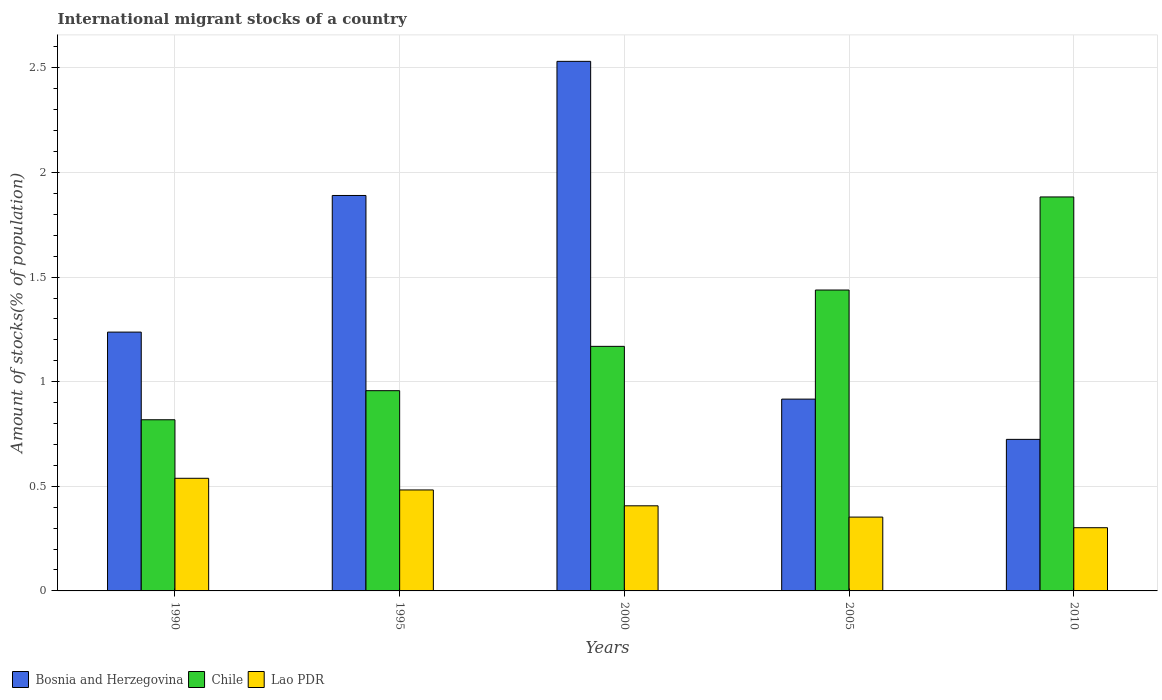Are the number of bars per tick equal to the number of legend labels?
Offer a terse response. Yes. How many bars are there on the 2nd tick from the right?
Offer a very short reply. 3. In how many cases, is the number of bars for a given year not equal to the number of legend labels?
Offer a terse response. 0. What is the amount of stocks in in Bosnia and Herzegovina in 1990?
Your response must be concise. 1.24. Across all years, what is the maximum amount of stocks in in Chile?
Provide a succinct answer. 1.88. Across all years, what is the minimum amount of stocks in in Bosnia and Herzegovina?
Provide a succinct answer. 0.72. In which year was the amount of stocks in in Chile maximum?
Give a very brief answer. 2010. In which year was the amount of stocks in in Chile minimum?
Your answer should be compact. 1990. What is the total amount of stocks in in Chile in the graph?
Your answer should be compact. 6.27. What is the difference between the amount of stocks in in Chile in 1995 and that in 2000?
Make the answer very short. -0.21. What is the difference between the amount of stocks in in Bosnia and Herzegovina in 2000 and the amount of stocks in in Chile in 2005?
Offer a terse response. 1.09. What is the average amount of stocks in in Lao PDR per year?
Your response must be concise. 0.42. In the year 1995, what is the difference between the amount of stocks in in Chile and amount of stocks in in Lao PDR?
Your response must be concise. 0.47. In how many years, is the amount of stocks in in Chile greater than 1.5 %?
Offer a very short reply. 1. What is the ratio of the amount of stocks in in Bosnia and Herzegovina in 1990 to that in 2005?
Offer a very short reply. 1.35. What is the difference between the highest and the second highest amount of stocks in in Chile?
Make the answer very short. 0.44. What is the difference between the highest and the lowest amount of stocks in in Bosnia and Herzegovina?
Provide a short and direct response. 1.81. In how many years, is the amount of stocks in in Bosnia and Herzegovina greater than the average amount of stocks in in Bosnia and Herzegovina taken over all years?
Provide a short and direct response. 2. Is the sum of the amount of stocks in in Chile in 1990 and 2000 greater than the maximum amount of stocks in in Bosnia and Herzegovina across all years?
Provide a short and direct response. No. What does the 3rd bar from the left in 2000 represents?
Provide a short and direct response. Lao PDR. What does the 1st bar from the right in 2000 represents?
Provide a succinct answer. Lao PDR. Is it the case that in every year, the sum of the amount of stocks in in Lao PDR and amount of stocks in in Chile is greater than the amount of stocks in in Bosnia and Herzegovina?
Offer a terse response. No. Does the graph contain any zero values?
Your response must be concise. No. Does the graph contain grids?
Keep it short and to the point. Yes. Where does the legend appear in the graph?
Your answer should be compact. Bottom left. How many legend labels are there?
Your answer should be compact. 3. How are the legend labels stacked?
Provide a short and direct response. Horizontal. What is the title of the graph?
Your answer should be compact. International migrant stocks of a country. What is the label or title of the Y-axis?
Your response must be concise. Amount of stocks(% of population). What is the Amount of stocks(% of population) in Bosnia and Herzegovina in 1990?
Your response must be concise. 1.24. What is the Amount of stocks(% of population) of Chile in 1990?
Ensure brevity in your answer.  0.82. What is the Amount of stocks(% of population) in Lao PDR in 1990?
Ensure brevity in your answer.  0.54. What is the Amount of stocks(% of population) in Bosnia and Herzegovina in 1995?
Keep it short and to the point. 1.89. What is the Amount of stocks(% of population) in Chile in 1995?
Make the answer very short. 0.96. What is the Amount of stocks(% of population) in Lao PDR in 1995?
Offer a very short reply. 0.48. What is the Amount of stocks(% of population) in Bosnia and Herzegovina in 2000?
Your response must be concise. 2.53. What is the Amount of stocks(% of population) of Chile in 2000?
Provide a succinct answer. 1.17. What is the Amount of stocks(% of population) of Lao PDR in 2000?
Provide a succinct answer. 0.41. What is the Amount of stocks(% of population) of Bosnia and Herzegovina in 2005?
Make the answer very short. 0.92. What is the Amount of stocks(% of population) of Chile in 2005?
Keep it short and to the point. 1.44. What is the Amount of stocks(% of population) in Lao PDR in 2005?
Your response must be concise. 0.35. What is the Amount of stocks(% of population) in Bosnia and Herzegovina in 2010?
Make the answer very short. 0.72. What is the Amount of stocks(% of population) in Chile in 2010?
Your answer should be compact. 1.88. What is the Amount of stocks(% of population) of Lao PDR in 2010?
Make the answer very short. 0.3. Across all years, what is the maximum Amount of stocks(% of population) of Bosnia and Herzegovina?
Give a very brief answer. 2.53. Across all years, what is the maximum Amount of stocks(% of population) in Chile?
Your answer should be compact. 1.88. Across all years, what is the maximum Amount of stocks(% of population) of Lao PDR?
Offer a terse response. 0.54. Across all years, what is the minimum Amount of stocks(% of population) of Bosnia and Herzegovina?
Provide a succinct answer. 0.72. Across all years, what is the minimum Amount of stocks(% of population) of Chile?
Provide a short and direct response. 0.82. Across all years, what is the minimum Amount of stocks(% of population) in Lao PDR?
Make the answer very short. 0.3. What is the total Amount of stocks(% of population) in Bosnia and Herzegovina in the graph?
Your answer should be compact. 7.3. What is the total Amount of stocks(% of population) of Chile in the graph?
Provide a short and direct response. 6.27. What is the total Amount of stocks(% of population) in Lao PDR in the graph?
Your answer should be very brief. 2.08. What is the difference between the Amount of stocks(% of population) in Bosnia and Herzegovina in 1990 and that in 1995?
Your answer should be very brief. -0.65. What is the difference between the Amount of stocks(% of population) in Chile in 1990 and that in 1995?
Give a very brief answer. -0.14. What is the difference between the Amount of stocks(% of population) of Lao PDR in 1990 and that in 1995?
Make the answer very short. 0.06. What is the difference between the Amount of stocks(% of population) in Bosnia and Herzegovina in 1990 and that in 2000?
Your response must be concise. -1.29. What is the difference between the Amount of stocks(% of population) in Chile in 1990 and that in 2000?
Offer a very short reply. -0.35. What is the difference between the Amount of stocks(% of population) in Lao PDR in 1990 and that in 2000?
Your answer should be compact. 0.13. What is the difference between the Amount of stocks(% of population) in Bosnia and Herzegovina in 1990 and that in 2005?
Provide a succinct answer. 0.32. What is the difference between the Amount of stocks(% of population) of Chile in 1990 and that in 2005?
Your answer should be very brief. -0.62. What is the difference between the Amount of stocks(% of population) in Lao PDR in 1990 and that in 2005?
Your answer should be very brief. 0.19. What is the difference between the Amount of stocks(% of population) of Bosnia and Herzegovina in 1990 and that in 2010?
Keep it short and to the point. 0.51. What is the difference between the Amount of stocks(% of population) of Chile in 1990 and that in 2010?
Provide a short and direct response. -1.06. What is the difference between the Amount of stocks(% of population) of Lao PDR in 1990 and that in 2010?
Give a very brief answer. 0.24. What is the difference between the Amount of stocks(% of population) of Bosnia and Herzegovina in 1995 and that in 2000?
Your answer should be very brief. -0.64. What is the difference between the Amount of stocks(% of population) in Chile in 1995 and that in 2000?
Your response must be concise. -0.21. What is the difference between the Amount of stocks(% of population) of Lao PDR in 1995 and that in 2000?
Give a very brief answer. 0.08. What is the difference between the Amount of stocks(% of population) in Bosnia and Herzegovina in 1995 and that in 2005?
Offer a terse response. 0.97. What is the difference between the Amount of stocks(% of population) in Chile in 1995 and that in 2005?
Keep it short and to the point. -0.48. What is the difference between the Amount of stocks(% of population) of Lao PDR in 1995 and that in 2005?
Your answer should be very brief. 0.13. What is the difference between the Amount of stocks(% of population) of Bosnia and Herzegovina in 1995 and that in 2010?
Give a very brief answer. 1.17. What is the difference between the Amount of stocks(% of population) of Chile in 1995 and that in 2010?
Offer a terse response. -0.93. What is the difference between the Amount of stocks(% of population) in Lao PDR in 1995 and that in 2010?
Provide a short and direct response. 0.18. What is the difference between the Amount of stocks(% of population) in Bosnia and Herzegovina in 2000 and that in 2005?
Provide a succinct answer. 1.61. What is the difference between the Amount of stocks(% of population) in Chile in 2000 and that in 2005?
Give a very brief answer. -0.27. What is the difference between the Amount of stocks(% of population) of Lao PDR in 2000 and that in 2005?
Give a very brief answer. 0.05. What is the difference between the Amount of stocks(% of population) of Bosnia and Herzegovina in 2000 and that in 2010?
Give a very brief answer. 1.81. What is the difference between the Amount of stocks(% of population) of Chile in 2000 and that in 2010?
Offer a terse response. -0.71. What is the difference between the Amount of stocks(% of population) in Lao PDR in 2000 and that in 2010?
Make the answer very short. 0.1. What is the difference between the Amount of stocks(% of population) of Bosnia and Herzegovina in 2005 and that in 2010?
Provide a succinct answer. 0.19. What is the difference between the Amount of stocks(% of population) in Chile in 2005 and that in 2010?
Make the answer very short. -0.44. What is the difference between the Amount of stocks(% of population) in Lao PDR in 2005 and that in 2010?
Keep it short and to the point. 0.05. What is the difference between the Amount of stocks(% of population) in Bosnia and Herzegovina in 1990 and the Amount of stocks(% of population) in Chile in 1995?
Provide a succinct answer. 0.28. What is the difference between the Amount of stocks(% of population) of Bosnia and Herzegovina in 1990 and the Amount of stocks(% of population) of Lao PDR in 1995?
Your response must be concise. 0.75. What is the difference between the Amount of stocks(% of population) in Chile in 1990 and the Amount of stocks(% of population) in Lao PDR in 1995?
Your answer should be compact. 0.34. What is the difference between the Amount of stocks(% of population) of Bosnia and Herzegovina in 1990 and the Amount of stocks(% of population) of Chile in 2000?
Your response must be concise. 0.07. What is the difference between the Amount of stocks(% of population) of Bosnia and Herzegovina in 1990 and the Amount of stocks(% of population) of Lao PDR in 2000?
Keep it short and to the point. 0.83. What is the difference between the Amount of stocks(% of population) in Chile in 1990 and the Amount of stocks(% of population) in Lao PDR in 2000?
Offer a very short reply. 0.41. What is the difference between the Amount of stocks(% of population) in Bosnia and Herzegovina in 1990 and the Amount of stocks(% of population) in Chile in 2005?
Provide a succinct answer. -0.2. What is the difference between the Amount of stocks(% of population) of Bosnia and Herzegovina in 1990 and the Amount of stocks(% of population) of Lao PDR in 2005?
Keep it short and to the point. 0.88. What is the difference between the Amount of stocks(% of population) in Chile in 1990 and the Amount of stocks(% of population) in Lao PDR in 2005?
Ensure brevity in your answer.  0.47. What is the difference between the Amount of stocks(% of population) in Bosnia and Herzegovina in 1990 and the Amount of stocks(% of population) in Chile in 2010?
Give a very brief answer. -0.65. What is the difference between the Amount of stocks(% of population) in Bosnia and Herzegovina in 1990 and the Amount of stocks(% of population) in Lao PDR in 2010?
Provide a succinct answer. 0.93. What is the difference between the Amount of stocks(% of population) of Chile in 1990 and the Amount of stocks(% of population) of Lao PDR in 2010?
Your answer should be very brief. 0.52. What is the difference between the Amount of stocks(% of population) in Bosnia and Herzegovina in 1995 and the Amount of stocks(% of population) in Chile in 2000?
Provide a short and direct response. 0.72. What is the difference between the Amount of stocks(% of population) in Bosnia and Herzegovina in 1995 and the Amount of stocks(% of population) in Lao PDR in 2000?
Ensure brevity in your answer.  1.48. What is the difference between the Amount of stocks(% of population) in Chile in 1995 and the Amount of stocks(% of population) in Lao PDR in 2000?
Give a very brief answer. 0.55. What is the difference between the Amount of stocks(% of population) of Bosnia and Herzegovina in 1995 and the Amount of stocks(% of population) of Chile in 2005?
Ensure brevity in your answer.  0.45. What is the difference between the Amount of stocks(% of population) in Bosnia and Herzegovina in 1995 and the Amount of stocks(% of population) in Lao PDR in 2005?
Ensure brevity in your answer.  1.54. What is the difference between the Amount of stocks(% of population) of Chile in 1995 and the Amount of stocks(% of population) of Lao PDR in 2005?
Your answer should be compact. 0.6. What is the difference between the Amount of stocks(% of population) of Bosnia and Herzegovina in 1995 and the Amount of stocks(% of population) of Chile in 2010?
Make the answer very short. 0.01. What is the difference between the Amount of stocks(% of population) in Bosnia and Herzegovina in 1995 and the Amount of stocks(% of population) in Lao PDR in 2010?
Keep it short and to the point. 1.59. What is the difference between the Amount of stocks(% of population) in Chile in 1995 and the Amount of stocks(% of population) in Lao PDR in 2010?
Give a very brief answer. 0.65. What is the difference between the Amount of stocks(% of population) in Bosnia and Herzegovina in 2000 and the Amount of stocks(% of population) in Chile in 2005?
Give a very brief answer. 1.09. What is the difference between the Amount of stocks(% of population) of Bosnia and Herzegovina in 2000 and the Amount of stocks(% of population) of Lao PDR in 2005?
Provide a succinct answer. 2.18. What is the difference between the Amount of stocks(% of population) of Chile in 2000 and the Amount of stocks(% of population) of Lao PDR in 2005?
Ensure brevity in your answer.  0.82. What is the difference between the Amount of stocks(% of population) in Bosnia and Herzegovina in 2000 and the Amount of stocks(% of population) in Chile in 2010?
Keep it short and to the point. 0.65. What is the difference between the Amount of stocks(% of population) in Bosnia and Herzegovina in 2000 and the Amount of stocks(% of population) in Lao PDR in 2010?
Offer a very short reply. 2.23. What is the difference between the Amount of stocks(% of population) of Chile in 2000 and the Amount of stocks(% of population) of Lao PDR in 2010?
Provide a short and direct response. 0.87. What is the difference between the Amount of stocks(% of population) of Bosnia and Herzegovina in 2005 and the Amount of stocks(% of population) of Chile in 2010?
Provide a short and direct response. -0.97. What is the difference between the Amount of stocks(% of population) in Bosnia and Herzegovina in 2005 and the Amount of stocks(% of population) in Lao PDR in 2010?
Give a very brief answer. 0.61. What is the difference between the Amount of stocks(% of population) in Chile in 2005 and the Amount of stocks(% of population) in Lao PDR in 2010?
Make the answer very short. 1.14. What is the average Amount of stocks(% of population) of Bosnia and Herzegovina per year?
Give a very brief answer. 1.46. What is the average Amount of stocks(% of population) in Chile per year?
Keep it short and to the point. 1.25. What is the average Amount of stocks(% of population) in Lao PDR per year?
Ensure brevity in your answer.  0.42. In the year 1990, what is the difference between the Amount of stocks(% of population) in Bosnia and Herzegovina and Amount of stocks(% of population) in Chile?
Provide a succinct answer. 0.42. In the year 1990, what is the difference between the Amount of stocks(% of population) in Bosnia and Herzegovina and Amount of stocks(% of population) in Lao PDR?
Give a very brief answer. 0.7. In the year 1990, what is the difference between the Amount of stocks(% of population) of Chile and Amount of stocks(% of population) of Lao PDR?
Make the answer very short. 0.28. In the year 1995, what is the difference between the Amount of stocks(% of population) in Bosnia and Herzegovina and Amount of stocks(% of population) in Chile?
Your response must be concise. 0.93. In the year 1995, what is the difference between the Amount of stocks(% of population) of Bosnia and Herzegovina and Amount of stocks(% of population) of Lao PDR?
Provide a short and direct response. 1.41. In the year 1995, what is the difference between the Amount of stocks(% of population) of Chile and Amount of stocks(% of population) of Lao PDR?
Provide a short and direct response. 0.47. In the year 2000, what is the difference between the Amount of stocks(% of population) of Bosnia and Herzegovina and Amount of stocks(% of population) of Chile?
Your answer should be compact. 1.36. In the year 2000, what is the difference between the Amount of stocks(% of population) of Bosnia and Herzegovina and Amount of stocks(% of population) of Lao PDR?
Offer a very short reply. 2.12. In the year 2000, what is the difference between the Amount of stocks(% of population) of Chile and Amount of stocks(% of population) of Lao PDR?
Your response must be concise. 0.76. In the year 2005, what is the difference between the Amount of stocks(% of population) in Bosnia and Herzegovina and Amount of stocks(% of population) in Chile?
Your response must be concise. -0.52. In the year 2005, what is the difference between the Amount of stocks(% of population) of Bosnia and Herzegovina and Amount of stocks(% of population) of Lao PDR?
Your answer should be compact. 0.56. In the year 2005, what is the difference between the Amount of stocks(% of population) in Chile and Amount of stocks(% of population) in Lao PDR?
Keep it short and to the point. 1.09. In the year 2010, what is the difference between the Amount of stocks(% of population) in Bosnia and Herzegovina and Amount of stocks(% of population) in Chile?
Your answer should be very brief. -1.16. In the year 2010, what is the difference between the Amount of stocks(% of population) in Bosnia and Herzegovina and Amount of stocks(% of population) in Lao PDR?
Provide a short and direct response. 0.42. In the year 2010, what is the difference between the Amount of stocks(% of population) in Chile and Amount of stocks(% of population) in Lao PDR?
Provide a succinct answer. 1.58. What is the ratio of the Amount of stocks(% of population) of Bosnia and Herzegovina in 1990 to that in 1995?
Give a very brief answer. 0.65. What is the ratio of the Amount of stocks(% of population) of Chile in 1990 to that in 1995?
Ensure brevity in your answer.  0.85. What is the ratio of the Amount of stocks(% of population) of Lao PDR in 1990 to that in 1995?
Provide a succinct answer. 1.12. What is the ratio of the Amount of stocks(% of population) of Bosnia and Herzegovina in 1990 to that in 2000?
Your response must be concise. 0.49. What is the ratio of the Amount of stocks(% of population) in Chile in 1990 to that in 2000?
Provide a short and direct response. 0.7. What is the ratio of the Amount of stocks(% of population) in Lao PDR in 1990 to that in 2000?
Give a very brief answer. 1.32. What is the ratio of the Amount of stocks(% of population) in Bosnia and Herzegovina in 1990 to that in 2005?
Your answer should be compact. 1.35. What is the ratio of the Amount of stocks(% of population) of Chile in 1990 to that in 2005?
Your answer should be very brief. 0.57. What is the ratio of the Amount of stocks(% of population) of Lao PDR in 1990 to that in 2005?
Give a very brief answer. 1.53. What is the ratio of the Amount of stocks(% of population) in Bosnia and Herzegovina in 1990 to that in 2010?
Make the answer very short. 1.71. What is the ratio of the Amount of stocks(% of population) in Chile in 1990 to that in 2010?
Your response must be concise. 0.43. What is the ratio of the Amount of stocks(% of population) in Lao PDR in 1990 to that in 2010?
Your response must be concise. 1.78. What is the ratio of the Amount of stocks(% of population) in Bosnia and Herzegovina in 1995 to that in 2000?
Keep it short and to the point. 0.75. What is the ratio of the Amount of stocks(% of population) in Chile in 1995 to that in 2000?
Offer a very short reply. 0.82. What is the ratio of the Amount of stocks(% of population) of Lao PDR in 1995 to that in 2000?
Your response must be concise. 1.19. What is the ratio of the Amount of stocks(% of population) in Bosnia and Herzegovina in 1995 to that in 2005?
Your response must be concise. 2.06. What is the ratio of the Amount of stocks(% of population) of Chile in 1995 to that in 2005?
Your response must be concise. 0.67. What is the ratio of the Amount of stocks(% of population) of Lao PDR in 1995 to that in 2005?
Your answer should be very brief. 1.37. What is the ratio of the Amount of stocks(% of population) of Bosnia and Herzegovina in 1995 to that in 2010?
Your answer should be very brief. 2.61. What is the ratio of the Amount of stocks(% of population) in Chile in 1995 to that in 2010?
Make the answer very short. 0.51. What is the ratio of the Amount of stocks(% of population) of Lao PDR in 1995 to that in 2010?
Make the answer very short. 1.6. What is the ratio of the Amount of stocks(% of population) in Bosnia and Herzegovina in 2000 to that in 2005?
Offer a terse response. 2.76. What is the ratio of the Amount of stocks(% of population) of Chile in 2000 to that in 2005?
Make the answer very short. 0.81. What is the ratio of the Amount of stocks(% of population) of Lao PDR in 2000 to that in 2005?
Give a very brief answer. 1.15. What is the ratio of the Amount of stocks(% of population) in Bosnia and Herzegovina in 2000 to that in 2010?
Keep it short and to the point. 3.49. What is the ratio of the Amount of stocks(% of population) in Chile in 2000 to that in 2010?
Provide a succinct answer. 0.62. What is the ratio of the Amount of stocks(% of population) of Lao PDR in 2000 to that in 2010?
Your answer should be compact. 1.35. What is the ratio of the Amount of stocks(% of population) in Bosnia and Herzegovina in 2005 to that in 2010?
Provide a short and direct response. 1.27. What is the ratio of the Amount of stocks(% of population) in Chile in 2005 to that in 2010?
Provide a succinct answer. 0.76. What is the ratio of the Amount of stocks(% of population) of Lao PDR in 2005 to that in 2010?
Make the answer very short. 1.17. What is the difference between the highest and the second highest Amount of stocks(% of population) of Bosnia and Herzegovina?
Provide a short and direct response. 0.64. What is the difference between the highest and the second highest Amount of stocks(% of population) in Chile?
Offer a very short reply. 0.44. What is the difference between the highest and the second highest Amount of stocks(% of population) of Lao PDR?
Make the answer very short. 0.06. What is the difference between the highest and the lowest Amount of stocks(% of population) in Bosnia and Herzegovina?
Give a very brief answer. 1.81. What is the difference between the highest and the lowest Amount of stocks(% of population) in Chile?
Keep it short and to the point. 1.06. What is the difference between the highest and the lowest Amount of stocks(% of population) of Lao PDR?
Offer a very short reply. 0.24. 